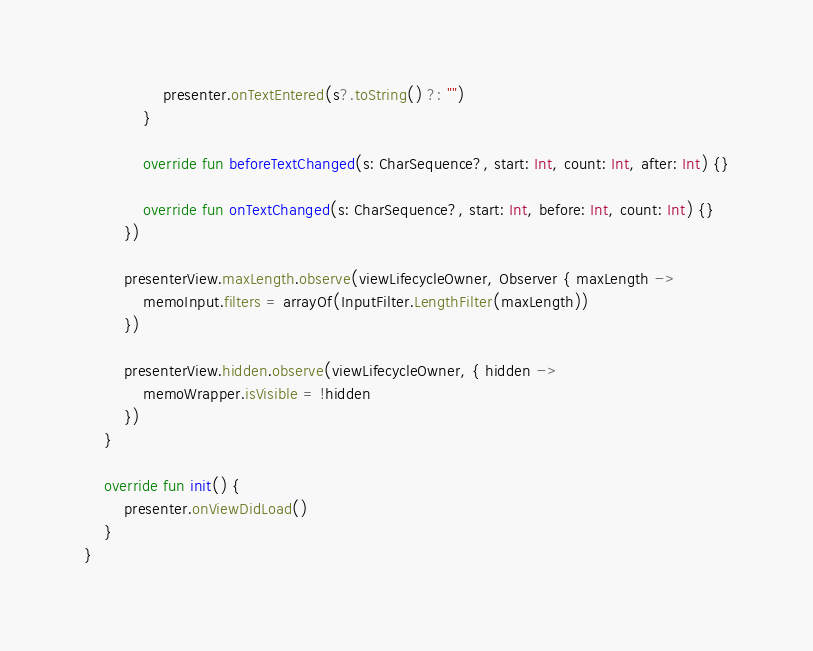Convert code to text. <code><loc_0><loc_0><loc_500><loc_500><_Kotlin_>                presenter.onTextEntered(s?.toString() ?: "")
            }

            override fun beforeTextChanged(s: CharSequence?, start: Int, count: Int, after: Int) {}

            override fun onTextChanged(s: CharSequence?, start: Int, before: Int, count: Int) {}
        })

        presenterView.maxLength.observe(viewLifecycleOwner, Observer { maxLength ->
            memoInput.filters = arrayOf(InputFilter.LengthFilter(maxLength))
        })

        presenterView.hidden.observe(viewLifecycleOwner, { hidden ->
            memoWrapper.isVisible = !hidden
        })
    }

    override fun init() {
        presenter.onViewDidLoad()
    }
}
</code> 